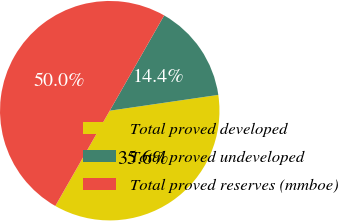Convert chart. <chart><loc_0><loc_0><loc_500><loc_500><pie_chart><fcel>Total proved developed<fcel>Total proved undeveloped<fcel>Total proved reserves (mmboe)<nl><fcel>35.56%<fcel>14.44%<fcel>50.0%<nl></chart> 